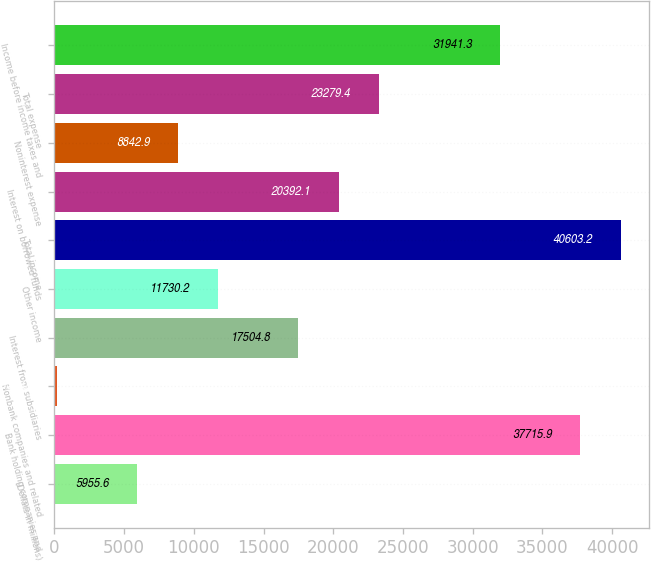<chart> <loc_0><loc_0><loc_500><loc_500><bar_chart><fcel>(Dollars in millions)<fcel>Bank holding companies and<fcel>Nonbank companies and related<fcel>Interest from subsidiaries<fcel>Other income<fcel>Total income<fcel>Interest on borrowed funds<fcel>Noninterest expense<fcel>Total expense<fcel>Income before income taxes and<nl><fcel>5955.6<fcel>37715.9<fcel>181<fcel>17504.8<fcel>11730.2<fcel>40603.2<fcel>20392.1<fcel>8842.9<fcel>23279.4<fcel>31941.3<nl></chart> 